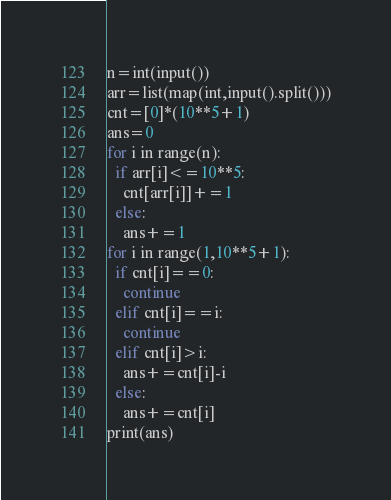Convert code to text. <code><loc_0><loc_0><loc_500><loc_500><_Python_>n=int(input())
arr=list(map(int,input().split()))
cnt=[0]*(10**5+1)
ans=0
for i in range(n):
  if arr[i]<=10**5:
    cnt[arr[i]]+=1
  else:
    ans+=1
for i in range(1,10**5+1):
  if cnt[i]==0:
    continue
  elif cnt[i]==i:
    continue
  elif cnt[i]>i:
    ans+=cnt[i]-i
  else:
    ans+=cnt[i]
print(ans)</code> 